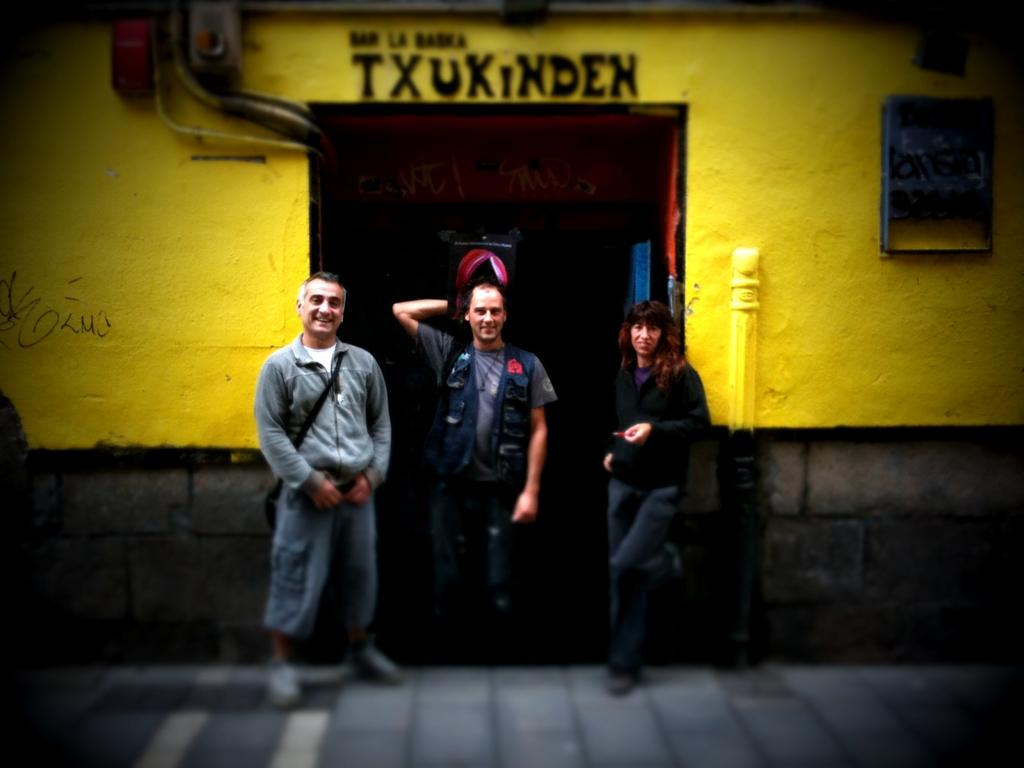What are the people in the image doing? The people in the image are standing beside a door. What can be seen around the door in the image? There is a frame visible around the door. What type of objects can be seen in the image that are related to plumbing or infrastructure? Pipes are visible in the image. What can be seen on the wall in the image? There are devices on a wall in the image. What type of information is present in the image? There is text present in the image. Can you see a mountain in the background of the image? There is no mountain visible in the image. What type of seat is present in the image? There is no seat present in the image. 